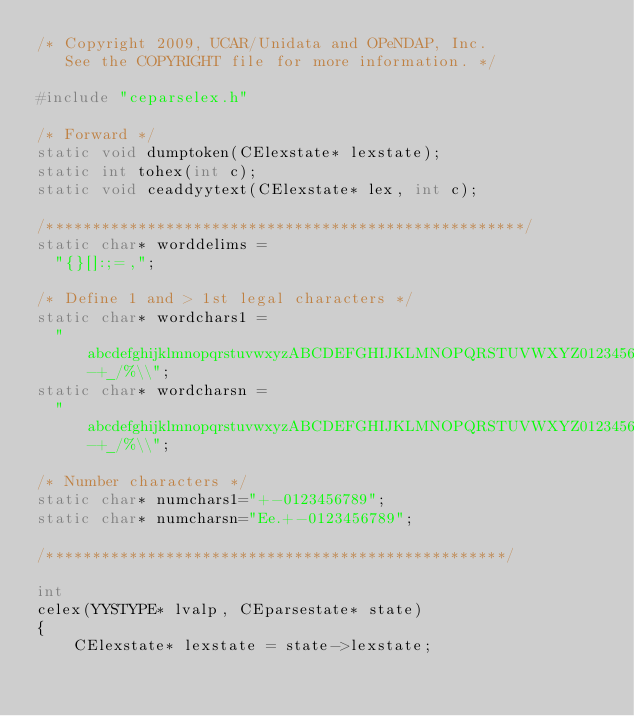<code> <loc_0><loc_0><loc_500><loc_500><_C_>/* Copyright 2009, UCAR/Unidata and OPeNDAP, Inc.
   See the COPYRIGHT file for more information. */

#include "ceparselex.h"

/* Forward */
static void dumptoken(CElexstate* lexstate);
static int tohex(int c);
static void ceaddyytext(CElexstate* lex, int c);

/****************************************************/
static char* worddelims =
  "{}[]:;=,";

/* Define 1 and > 1st legal characters */
static char* wordchars1 =
  "abcdefghijklmnopqrstuvwxyzABCDEFGHIJKLMNOPQRSTUVWXYZ0123456789-+_/%\\";
static char* wordcharsn =
  "abcdefghijklmnopqrstuvwxyzABCDEFGHIJKLMNOPQRSTUVWXYZ0123456789-+_/%\\";

/* Number characters */
static char* numchars1="+-0123456789";
static char* numcharsn="Ee.+-0123456789";

/**************************************************/

int
celex(YYSTYPE* lvalp, CEparsestate* state)
{
    CElexstate* lexstate = state->lexstate;</code> 